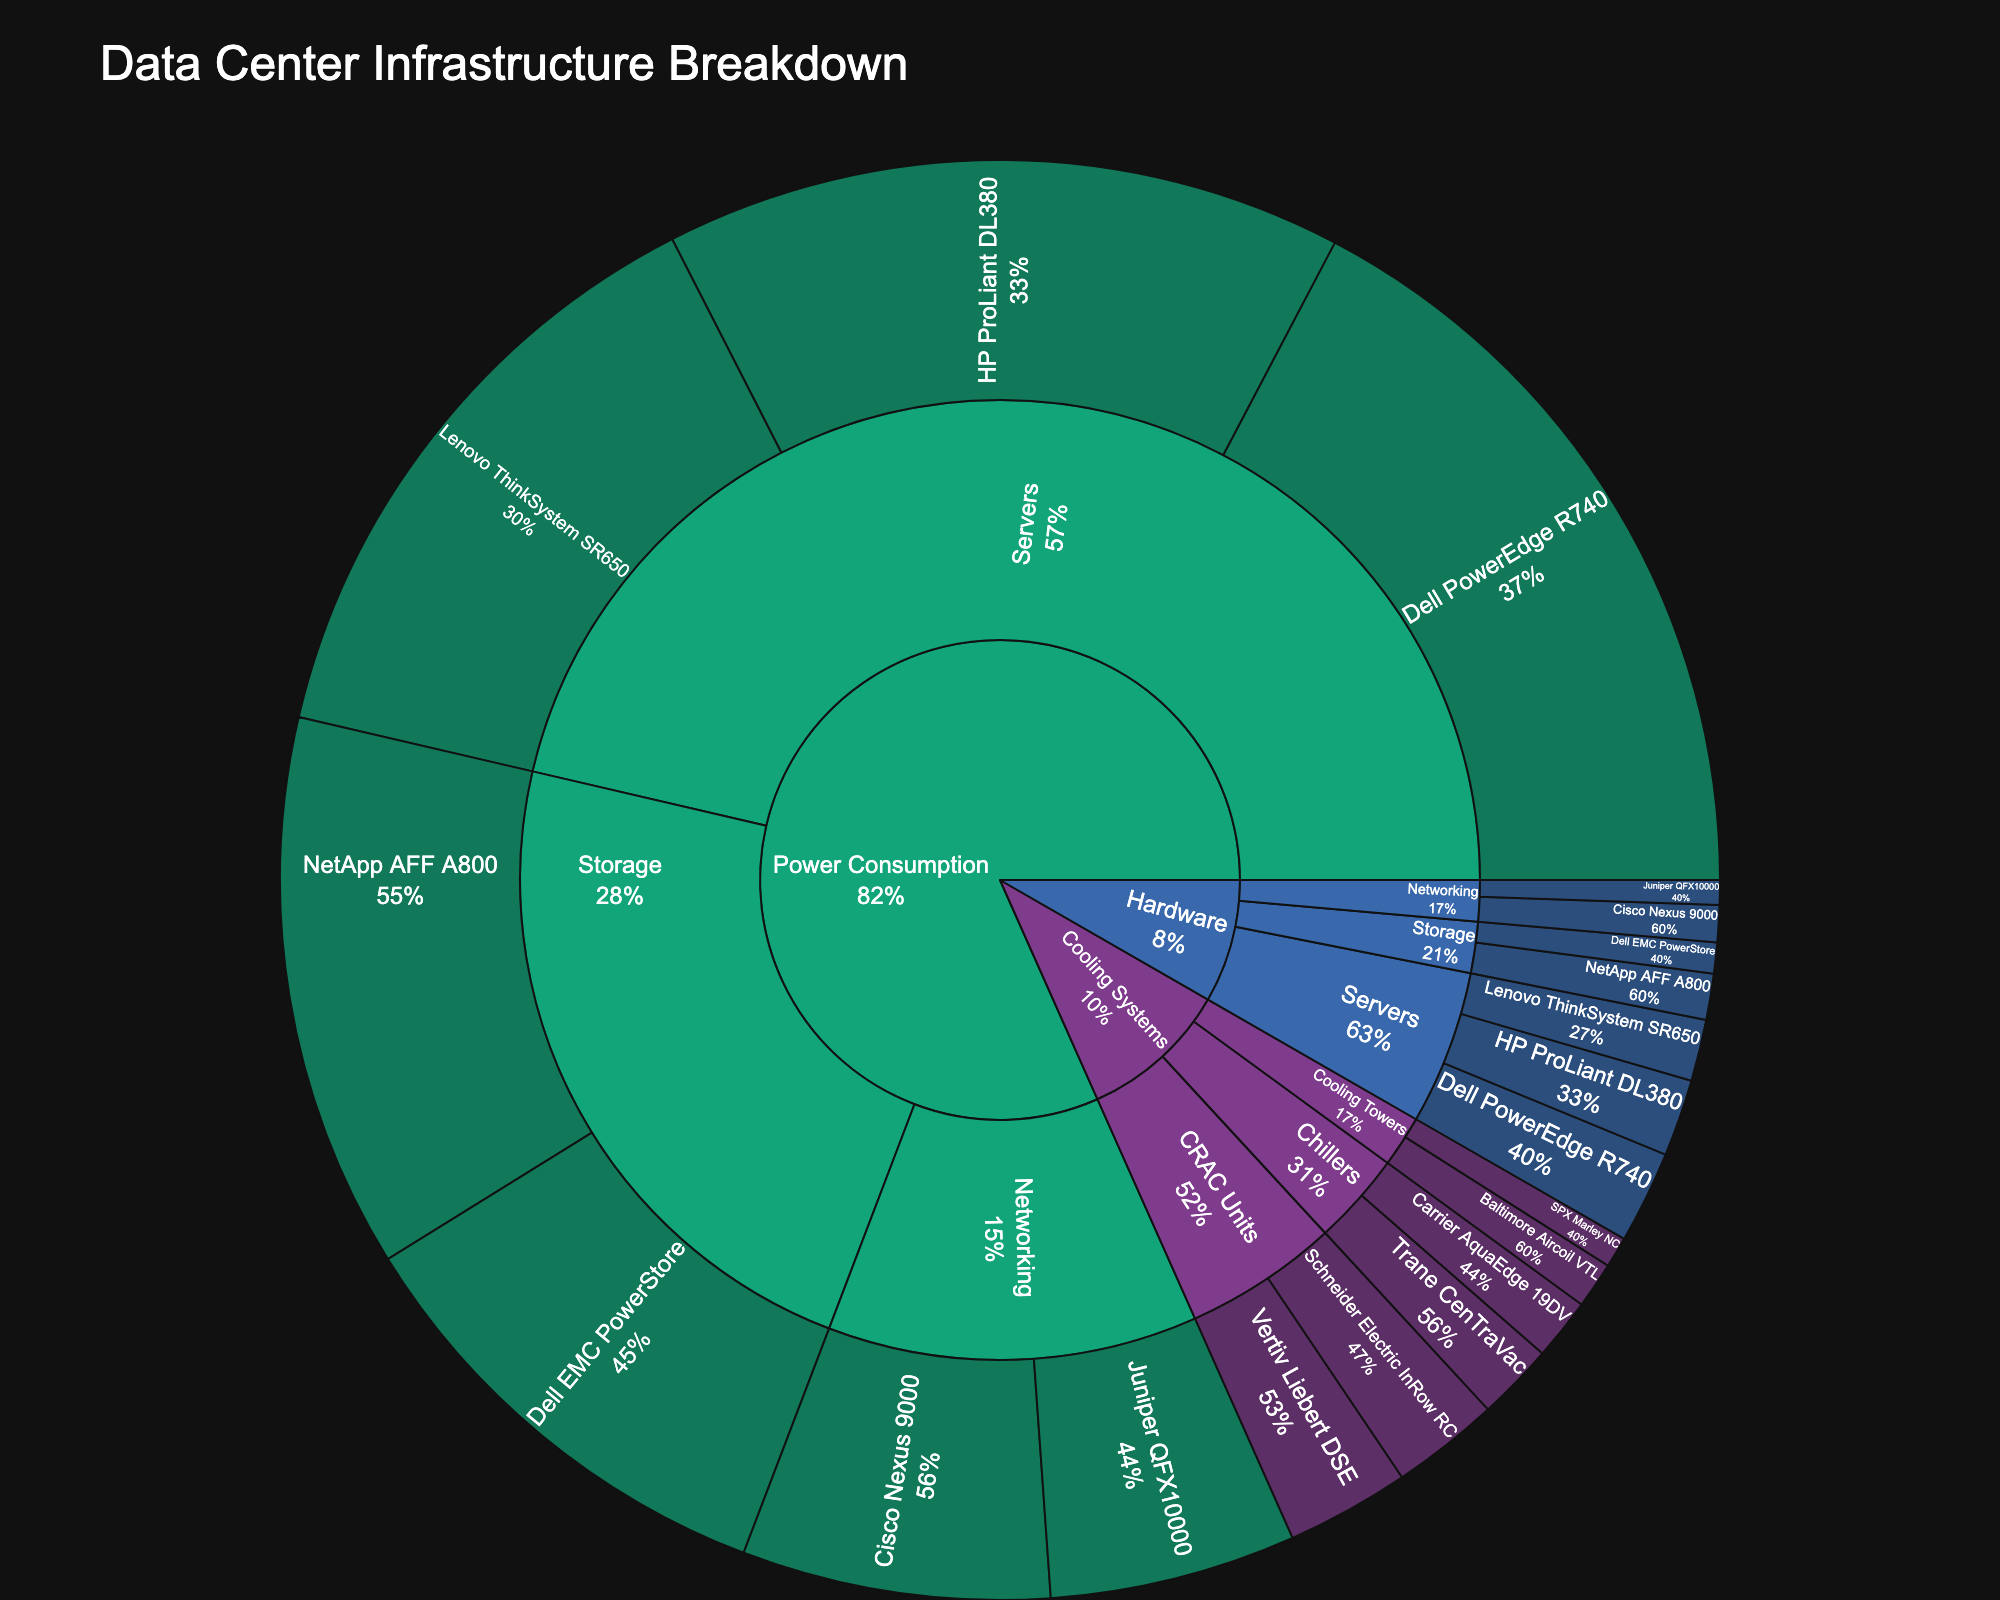What are the main categories displayed in the plot? The main categories are labeled on the outermost ring of the Sunburst Plot. They are typically shown with distinct colors.
Answer: Hardware, Power Consumption, Cooling Systems Which component within the Servers subcategory consumes the most power? Within the Servers subcategory under Power Consumption, look for the component with the largest segment. Dell PowerEdge R740 is the largest, indicating it consumes the most power.
Answer: Dell PowerEdge R740 How does the combined power consumption of the Dell PowerEdge R740 and HP ProLiant DL380 compare to the total power consumption of the Storage category? Sum the power consumption values of Dell PowerEdge R740 and HP ProLiant DL380 (250 + 220 = 470). Then, sum the power consumption values of all Storage components (180 + 150 = 330).
Answer: 470 is greater than 330 Which cooling system component has the smallest value, and what is it? Identify the segment with the smallest value among the Cooling Systems subcategory. SPX Marley NC in Cooling Towers has the smallest value.
Answer: SPX Marley NC What is the total value for all Networking hardware components combined? Sum the values of all Networking hardware components: Cisco Nexus 9000 and Juniper QFX10000 (12 + 8 = 20).
Answer: 20 In the Cooling Systems category, which subcategory has the highest total value? Add up the values of components in each subcategory and compare: CRAC Units (40 + 35 = 75), Chillers (25 + 20 = 45), Cooling Towers (15 + 10 = 25).
Answer: CRAC Units How does the value of Dell EMC PowerStore in the Hardware category compare to the power consumption value of the same component? Compare the values of Dell EMC PowerStore under Hardware and Power Consumption. Hardware value is 10, Power Consumption value is 150.
Answer: 10 is less than 150 Which subcategory in the Power Consumption category has the highest average component power consumption? Calculate the average power consumption for each subcategory: 
Servers: (250 + 220 + 200) / 3 = 670 / 3 ≈ 223.33;
Storage: (180 + 150) / 2 = 330 / 2 = 165;
Networking: (100 + 80) / 2 = 180 / 2 = 90. Compare these averages.
Answer: Servers Which component in the Cooling Towers subcategory of the Cooling Systems category has a higher value? Compare the values of Baltimore Aircoil VTL and SPX Marley NC in Cooling Towers. Baltimore Aircoil VTL has a value of 15, and SPX Marley NC has a value of 10.
Answer: Baltimore Aircoil VTL What is the total value for all components in the Power Consumption category? Sum the values of all components in the Power Consumption category: 250 + 220 + 200 + 180 + 150 + 100 + 80.
Answer: 1180 